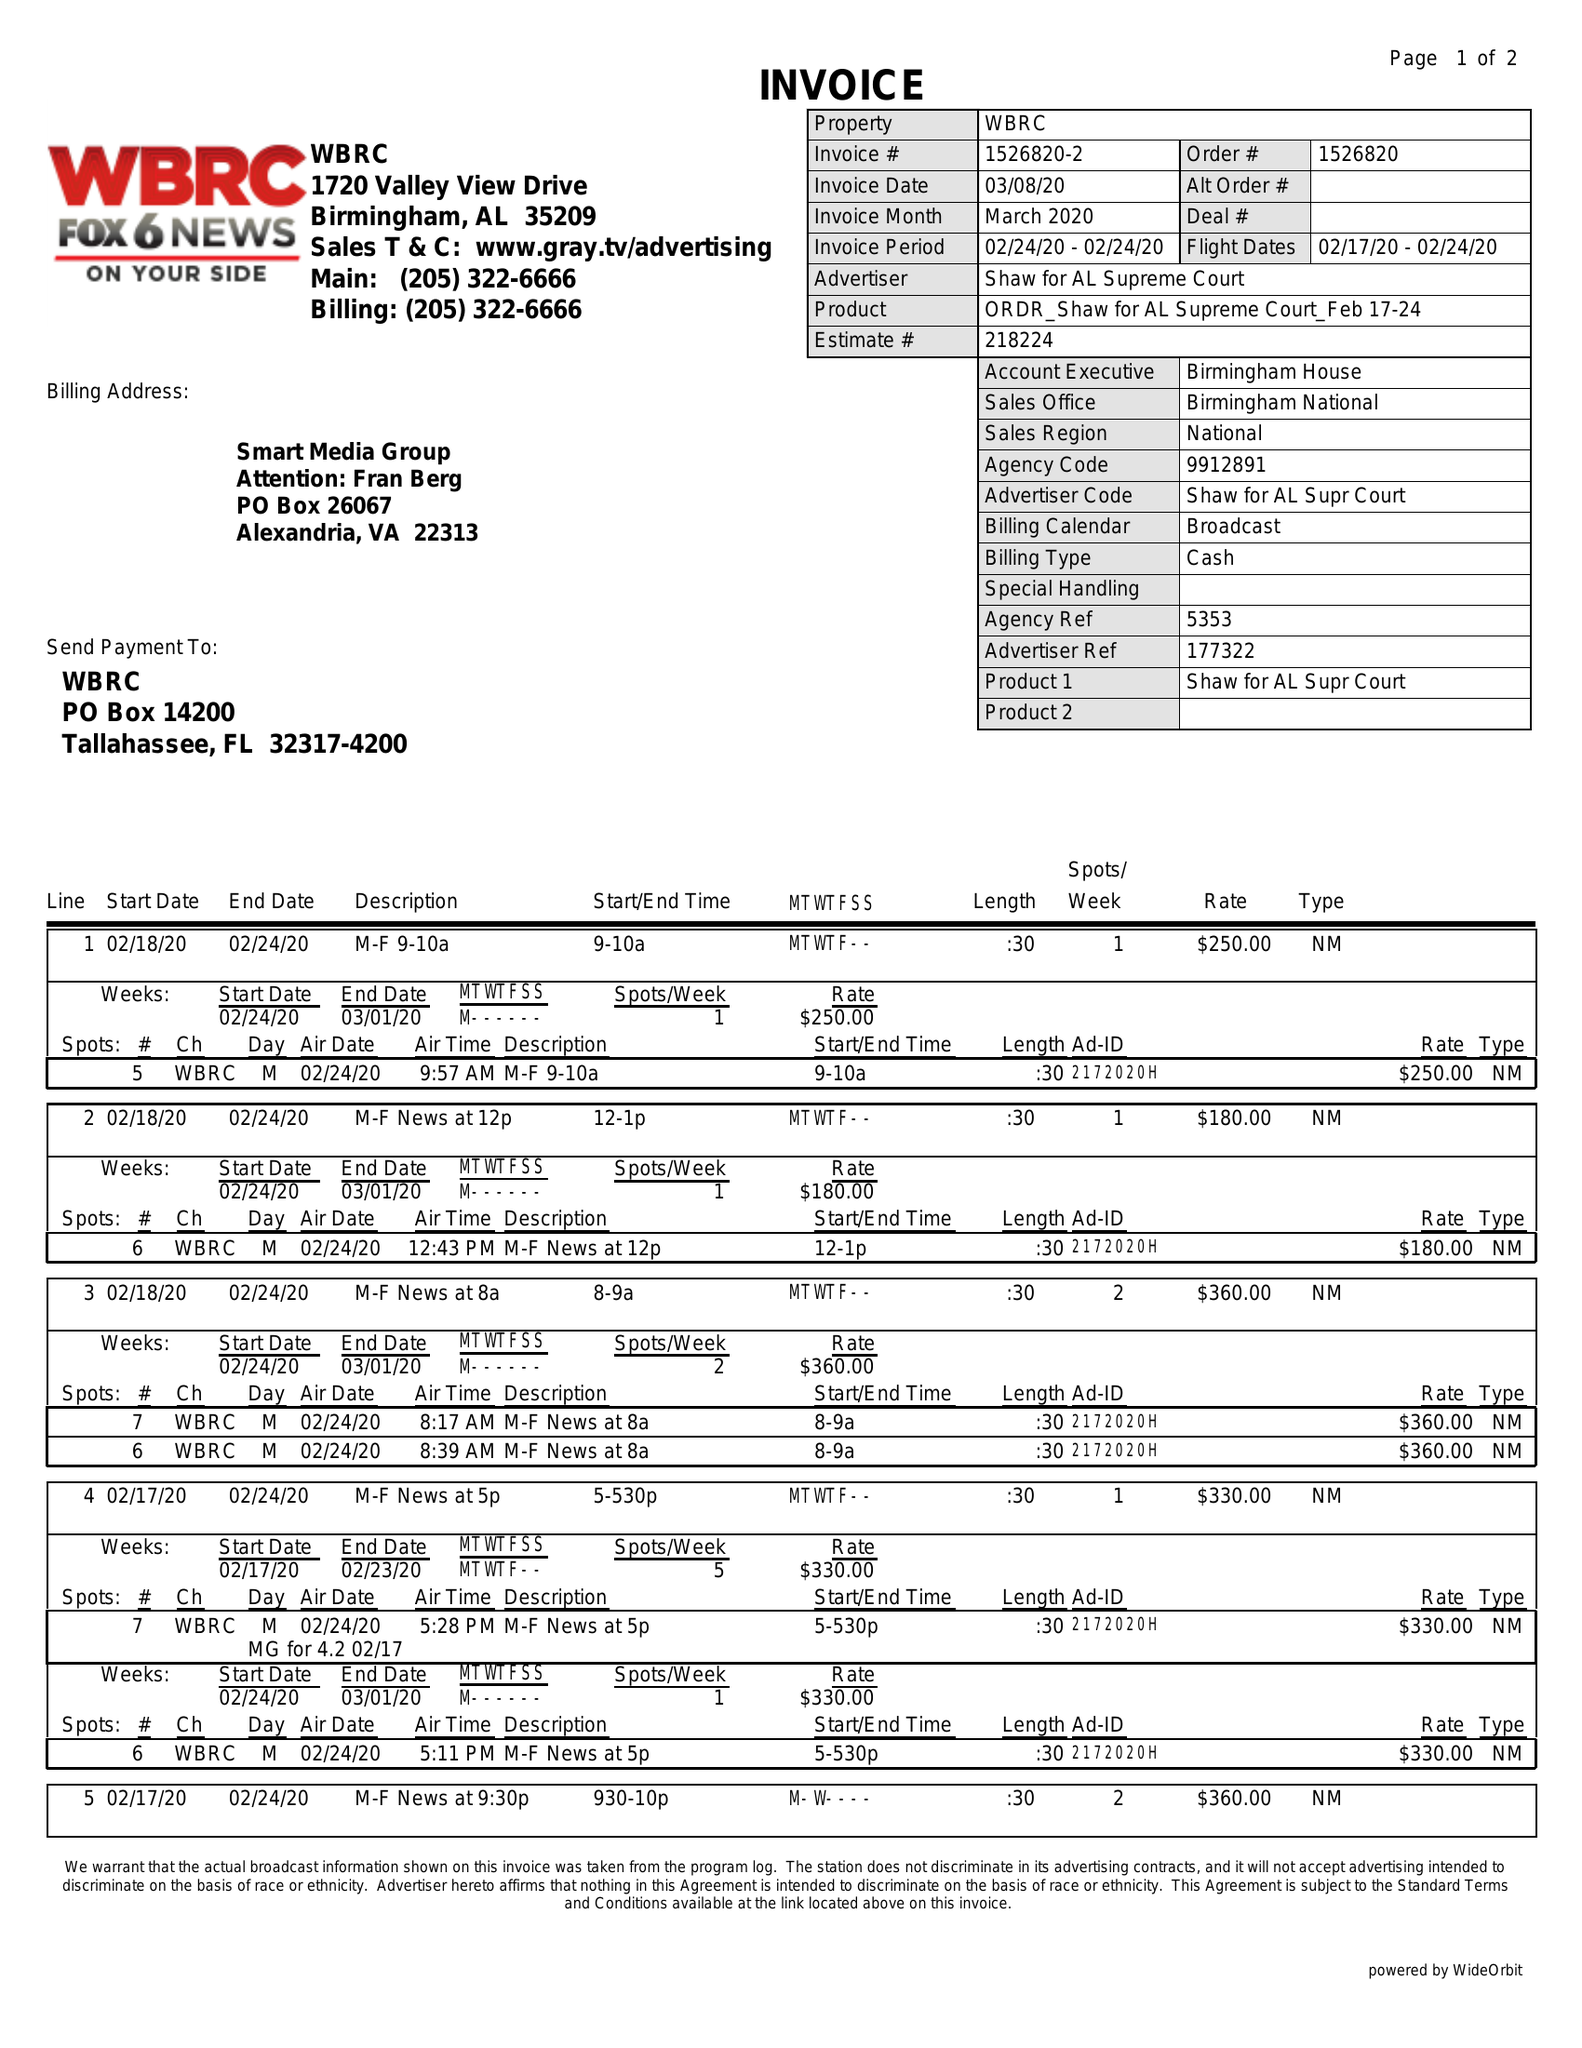What is the value for the flight_from?
Answer the question using a single word or phrase. 02/17/20 